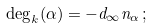<formula> <loc_0><loc_0><loc_500><loc_500>\deg _ { k } ( \alpha ) = - d _ { \infty } n _ { \alpha } \, ;</formula> 